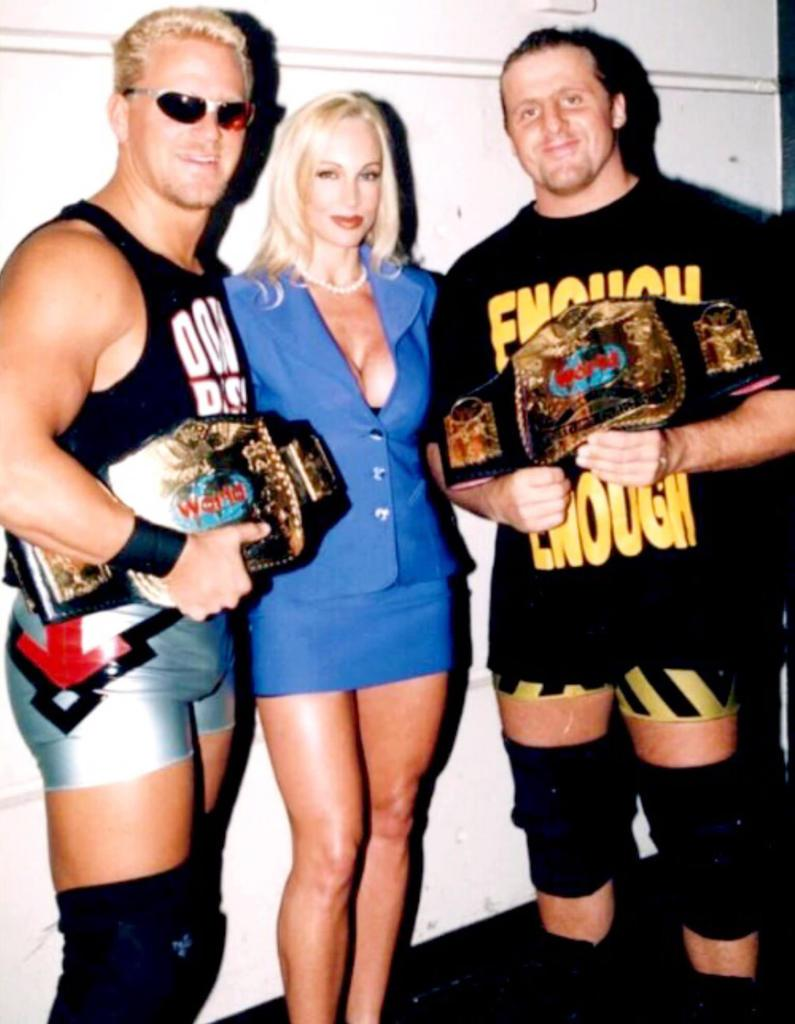<image>
Write a terse but informative summary of the picture. A woman is standing in between two wrestlers that are holding belts that say World on them. 